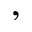<formula> <loc_0><loc_0><loc_500><loc_500>,</formula> 